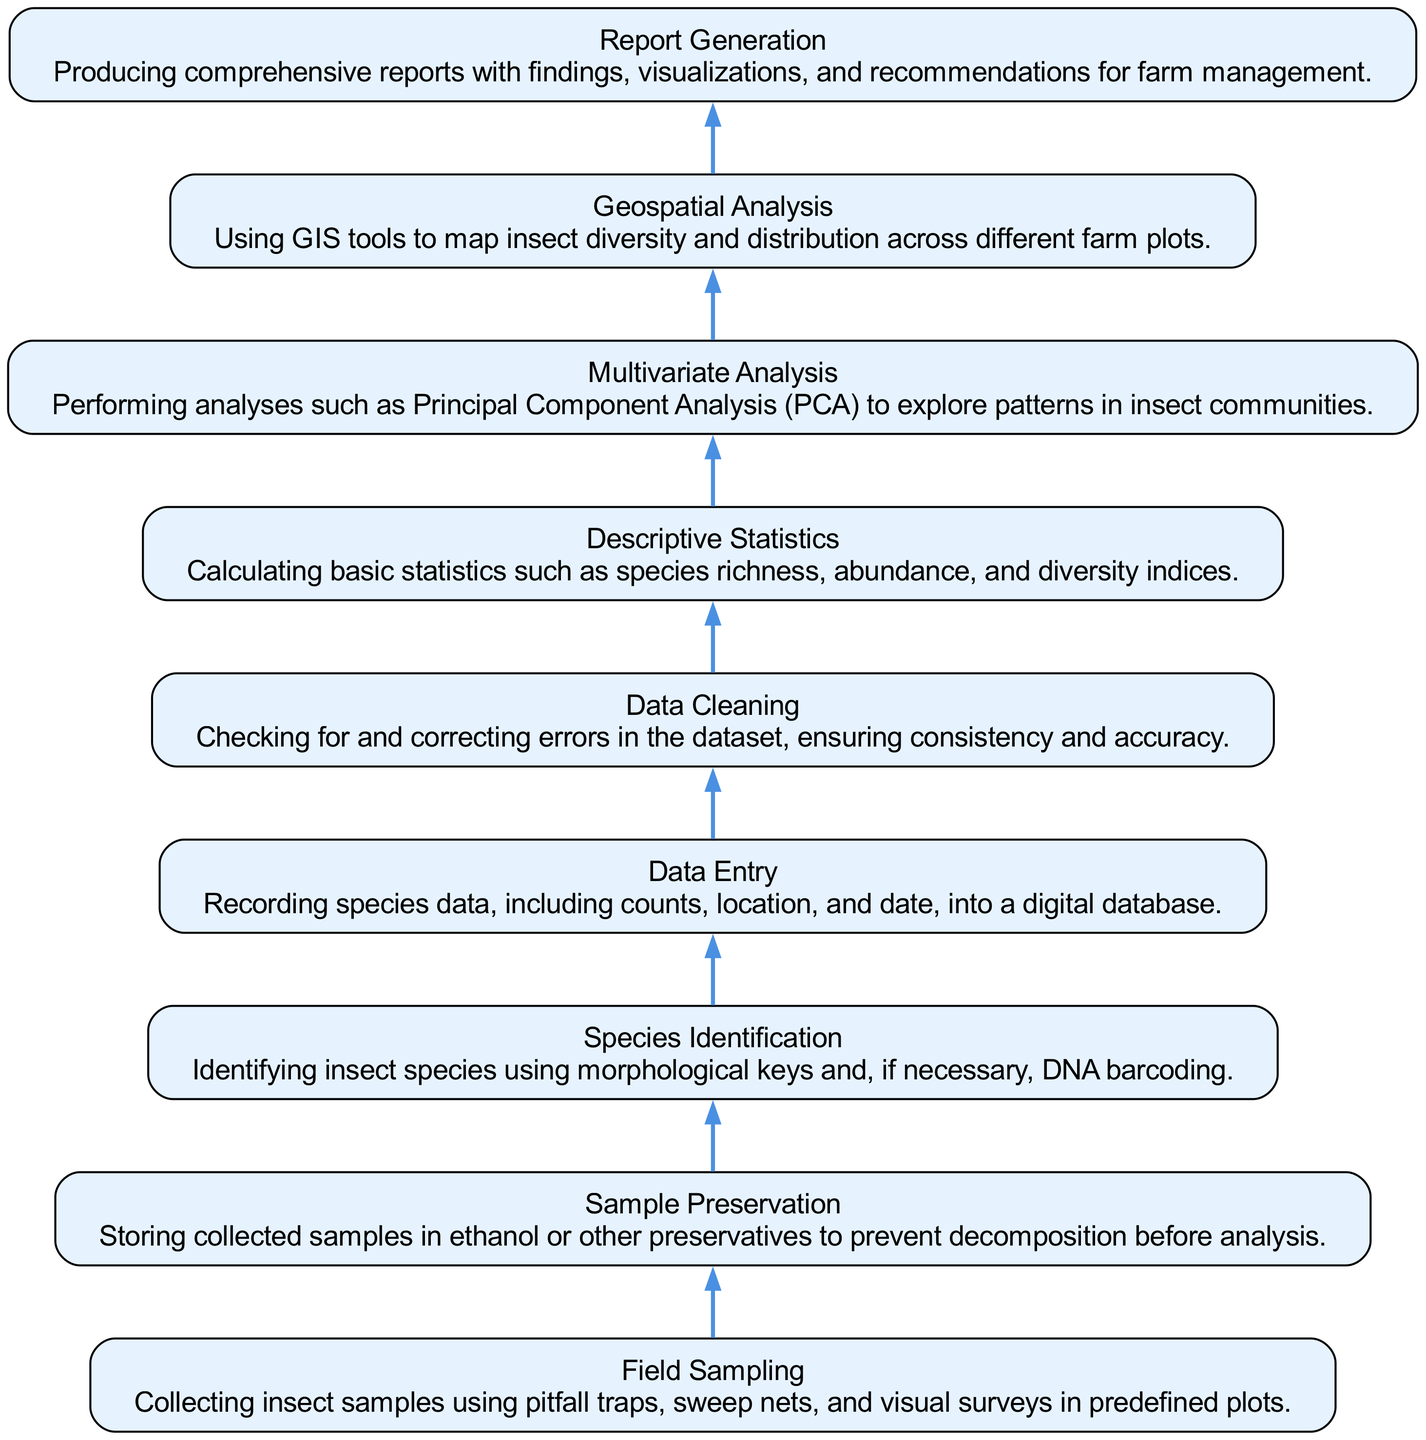What is the first step in the workflow? The first step listed in the diagram is "Field Sampling," which details the collection of insect samples using various methods.
Answer: Field Sampling How many total steps are present in the workflow? There are nine distinct steps in the workflow, each representing a key part of the data collection and analysis process.
Answer: Nine What precedes "Data Cleaning" in the workflow? The step that comes directly before "Data Cleaning" is "Data Entry," where species data is recorded into a digital database.
Answer: Data Entry What is the last step of the workflow? The final step shown in the diagram is "Report Generation," where comprehensive reports are created with all findings and recommendations.
Answer: Report Generation Which step involves using GIS tools? The "Geospatial Analysis" step involves using GIS tools to map insect diversity and distribution across different farm plots.
Answer: Geospatial Analysis What two steps are immediately connected to "Species Identification"? "Sample Preservation" precedes "Species Identification," and "Data Entry" follows it in the workflow.
Answer: Sample Preservation, Data Entry How do "Descriptive Statistics" and "Multivariate Analysis" relate to each other in the workflow? "Descriptive Statistics" comes directly before "Multivariate Analysis," indicating that basic statistics are calculated prior to performing more complex analyses.
Answer: Descriptive Statistics → Multivariate Analysis What is the purpose of the "Sample Preservation" step? The "Sample Preservation" step is essential for storing collected samples in a way that prevents decomposition before further analysis can take place.
Answer: Storing in ethanol or preservatives In what sequence do the steps occur from data collection to reporting? The sequence flows from "Field Sampling" at the bottom, then to "Sample Preservation," "Species Identification," "Data Entry," "Data Cleaning," "Descriptive Statistics," "Multivariate Analysis," "Geospatial Analysis," and finally to "Report Generation" at the top.
Answer: Field Sampling → Sample Preservation → Species Identification → Data Entry → Data Cleaning → Descriptive Statistics → Multivariate Analysis → Geospatial Analysis → Report Generation 